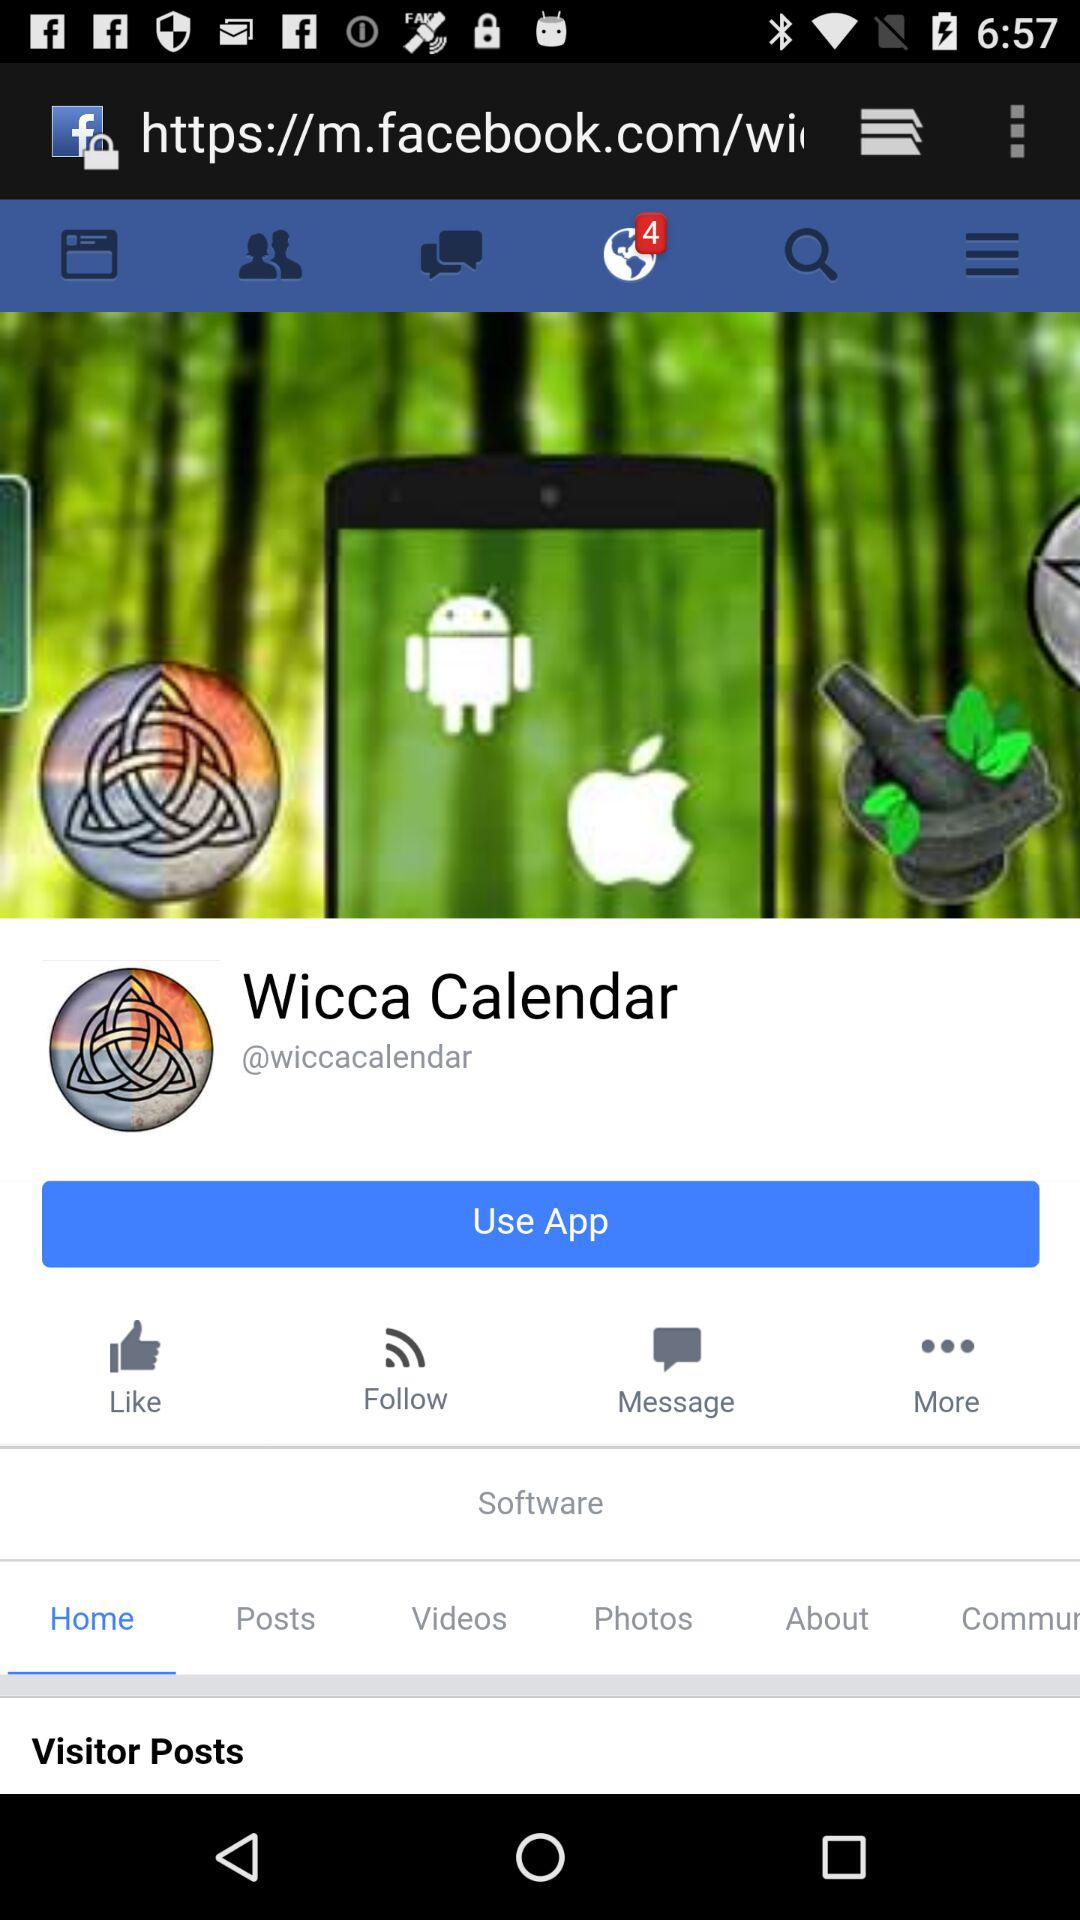What is the name of the application? The application name is "Wicca Calendar". 